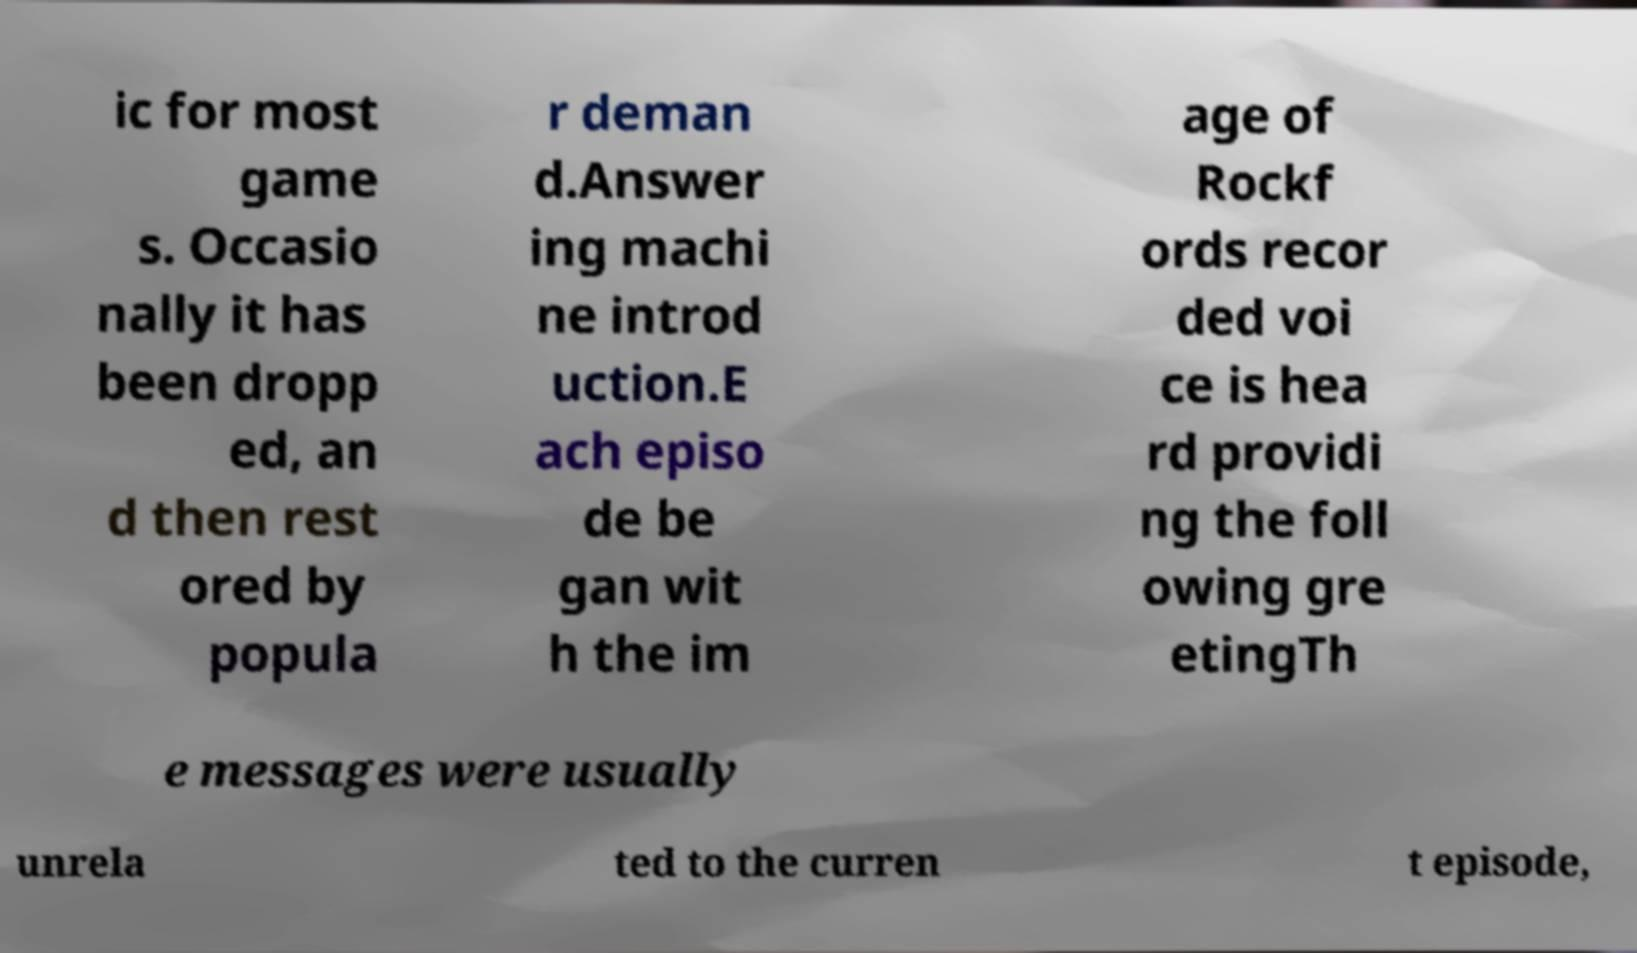Could you extract and type out the text from this image? ic for most game s. Occasio nally it has been dropp ed, an d then rest ored by popula r deman d.Answer ing machi ne introd uction.E ach episo de be gan wit h the im age of Rockf ords recor ded voi ce is hea rd providi ng the foll owing gre etingTh e messages were usually unrela ted to the curren t episode, 